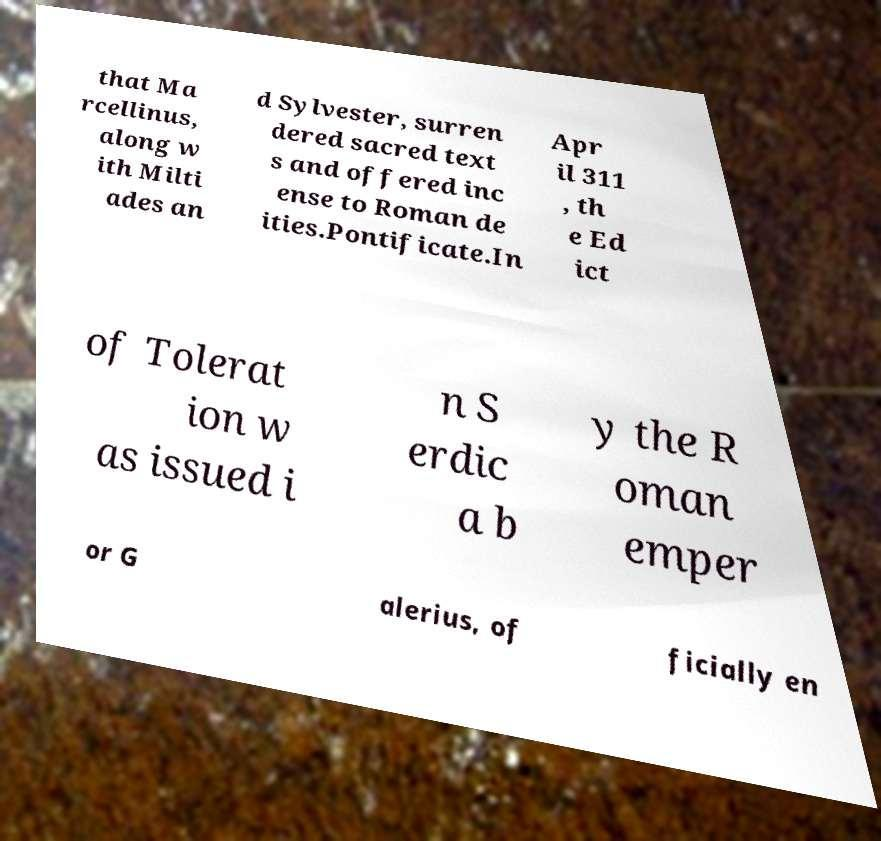Can you read and provide the text displayed in the image?This photo seems to have some interesting text. Can you extract and type it out for me? that Ma rcellinus, along w ith Milti ades an d Sylvester, surren dered sacred text s and offered inc ense to Roman de ities.Pontificate.In Apr il 311 , th e Ed ict of Tolerat ion w as issued i n S erdic a b y the R oman emper or G alerius, of ficially en 